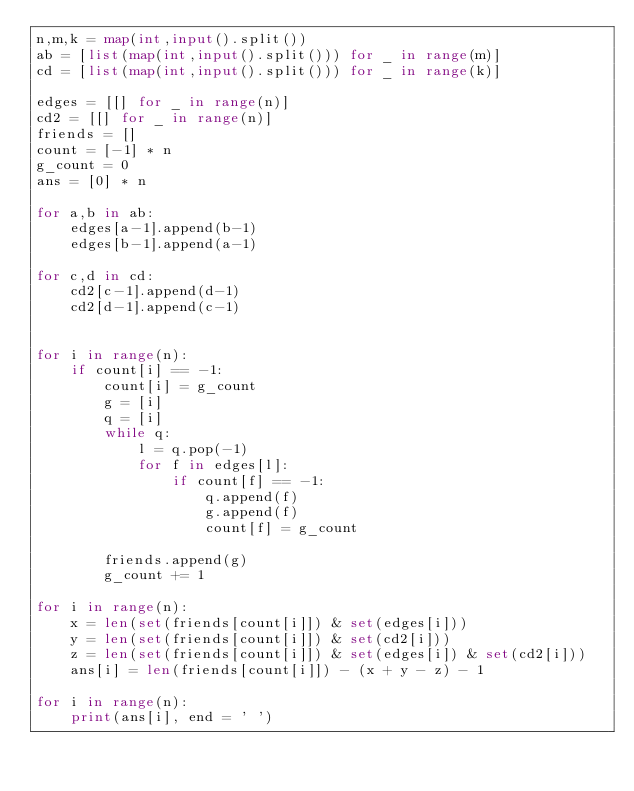<code> <loc_0><loc_0><loc_500><loc_500><_Python_>n,m,k = map(int,input().split())
ab = [list(map(int,input().split())) for _ in range(m)]
cd = [list(map(int,input().split())) for _ in range(k)]

edges = [[] for _ in range(n)]
cd2 = [[] for _ in range(n)]
friends = []
count = [-1] * n
g_count = 0
ans = [0] * n

for a,b in ab:
    edges[a-1].append(b-1)
    edges[b-1].append(a-1)

for c,d in cd:
    cd2[c-1].append(d-1)
    cd2[d-1].append(c-1)


for i in range(n):
    if count[i] == -1:
        count[i] = g_count
        g = [i]
        q = [i]
        while q:
            l = q.pop(-1)
            for f in edges[l]:
                if count[f] == -1:
                    q.append(f)
                    g.append(f)
                    count[f] = g_count

        friends.append(g)
        g_count += 1

for i in range(n):
    x = len(set(friends[count[i]]) & set(edges[i]))
    y = len(set(friends[count[i]]) & set(cd2[i]))
    z = len(set(friends[count[i]]) & set(edges[i]) & set(cd2[i]))
    ans[i] = len(friends[count[i]]) - (x + y - z) - 1

for i in range(n):
    print(ans[i], end = ' ')
</code> 